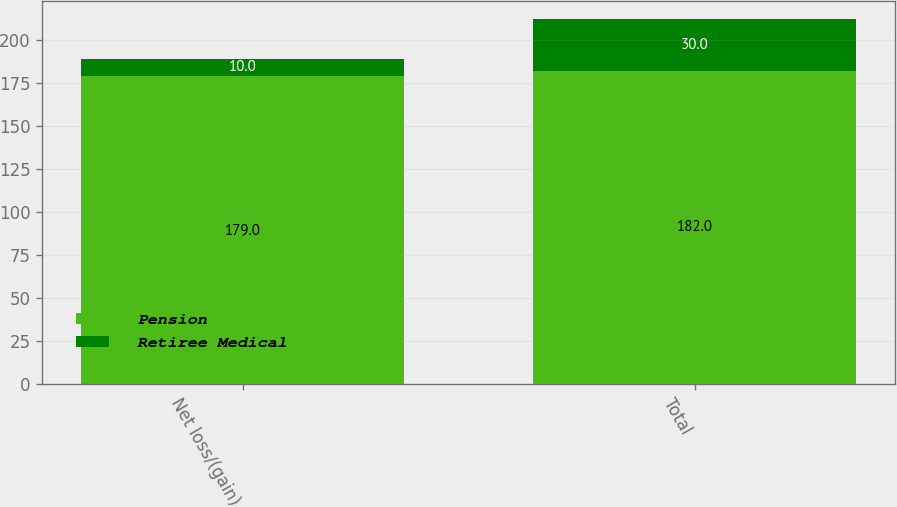Convert chart. <chart><loc_0><loc_0><loc_500><loc_500><stacked_bar_chart><ecel><fcel>Net loss/(gain)<fcel>Total<nl><fcel>Pension<fcel>179<fcel>182<nl><fcel>Retiree Medical<fcel>10<fcel>30<nl></chart> 